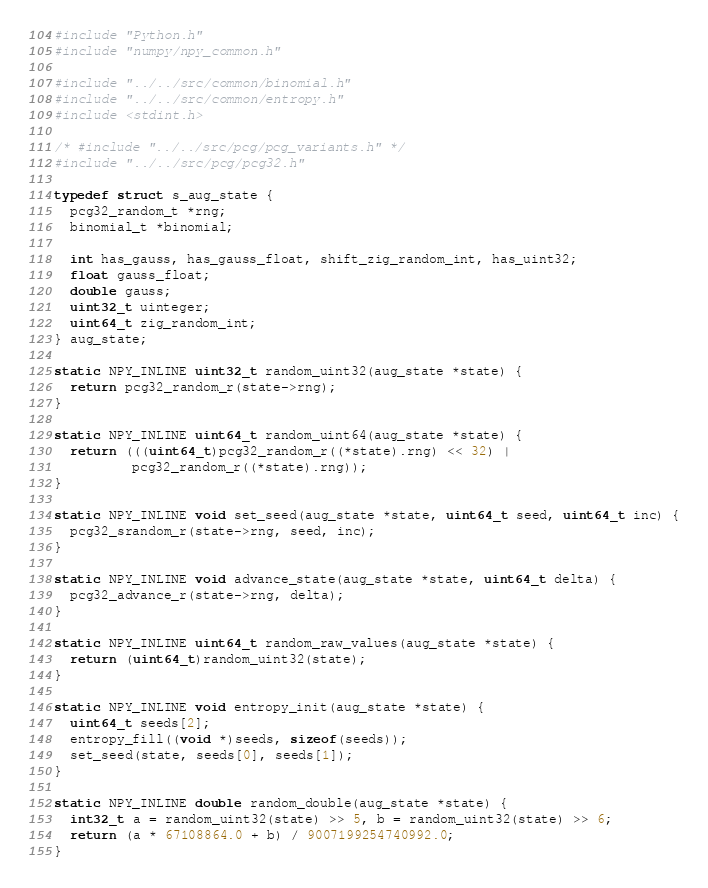Convert code to text. <code><loc_0><loc_0><loc_500><loc_500><_C_>#include "Python.h"
#include "numpy/npy_common.h"

#include "../../src/common/binomial.h"
#include "../../src/common/entropy.h"
#include <stdint.h>

/* #include "../../src/pcg/pcg_variants.h" */
#include "../../src/pcg/pcg32.h"

typedef struct s_aug_state {
  pcg32_random_t *rng;
  binomial_t *binomial;

  int has_gauss, has_gauss_float, shift_zig_random_int, has_uint32;
  float gauss_float;
  double gauss;
  uint32_t uinteger;
  uint64_t zig_random_int;
} aug_state;

static NPY_INLINE uint32_t random_uint32(aug_state *state) {
  return pcg32_random_r(state->rng);
}

static NPY_INLINE uint64_t random_uint64(aug_state *state) {
  return (((uint64_t)pcg32_random_r((*state).rng) << 32) |
          pcg32_random_r((*state).rng));
}

static NPY_INLINE void set_seed(aug_state *state, uint64_t seed, uint64_t inc) {
  pcg32_srandom_r(state->rng, seed, inc);
}

static NPY_INLINE void advance_state(aug_state *state, uint64_t delta) {
  pcg32_advance_r(state->rng, delta);
}

static NPY_INLINE uint64_t random_raw_values(aug_state *state) {
  return (uint64_t)random_uint32(state);
}

static NPY_INLINE void entropy_init(aug_state *state) {
  uint64_t seeds[2];
  entropy_fill((void *)seeds, sizeof(seeds));
  set_seed(state, seeds[0], seeds[1]);
}

static NPY_INLINE double random_double(aug_state *state) {
  int32_t a = random_uint32(state) >> 5, b = random_uint32(state) >> 6;
  return (a * 67108864.0 + b) / 9007199254740992.0;
}</code> 